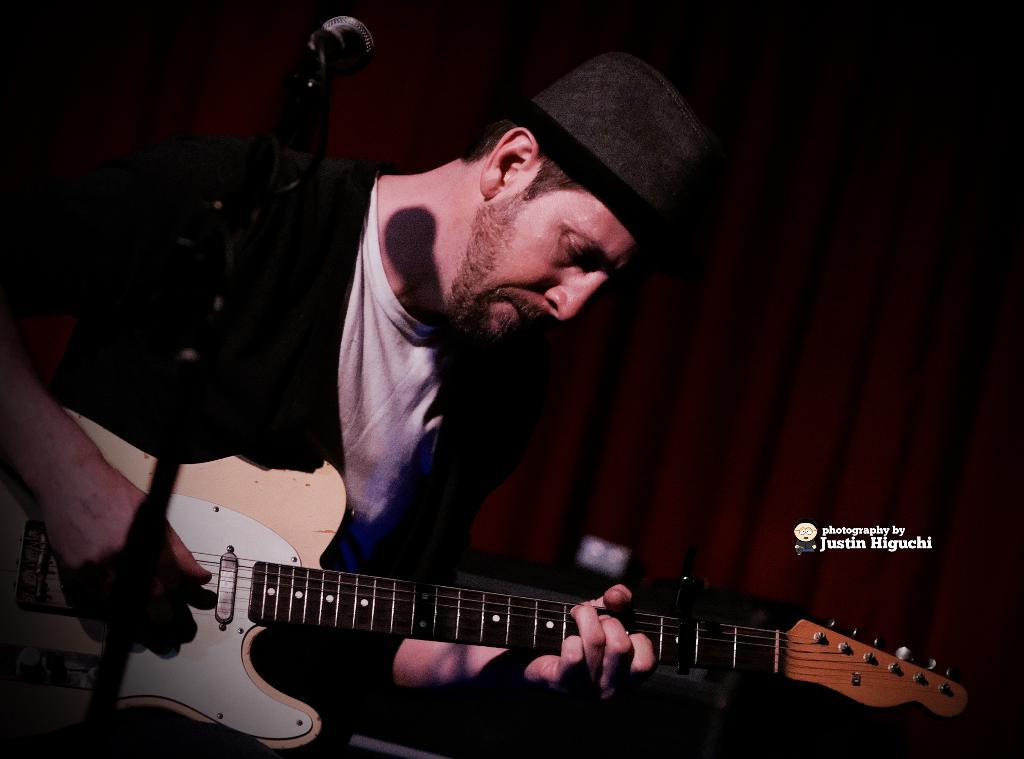What is the man in the image doing? The man is sitting and playing the guitar. What object is associated with the man's activity in the image? There is a microphone in the image. Can you describe the microphone's support in the image? There is a stand associated with the microphone in the image. Is the man in the image trying to escape from jail? There is no indication of a jail or any related activity in the image; the man is playing the guitar and using a microphone. 